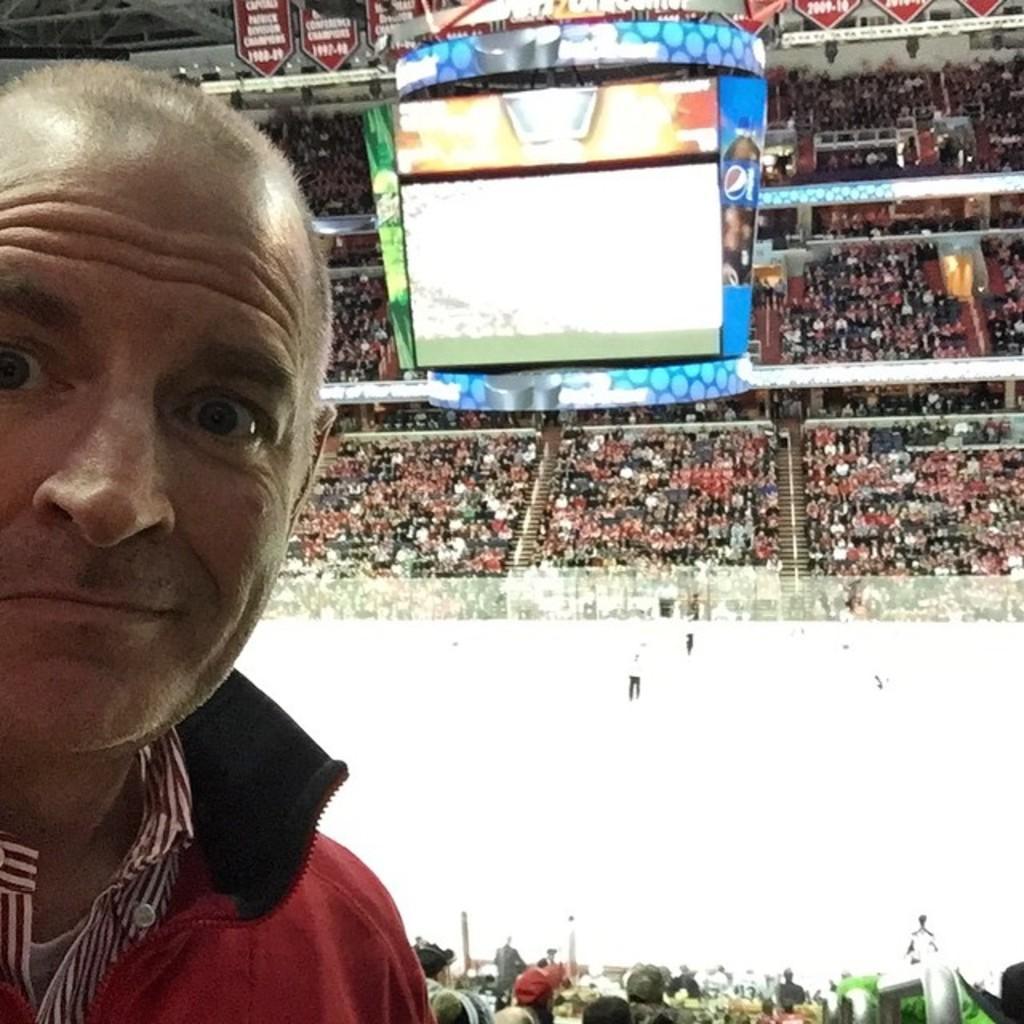Please provide a concise description of this image. This is a picture of a stadium. In this picture we can see the crowd, stairs, screen, objects and boards. On the left side of the picture we can see a man. 